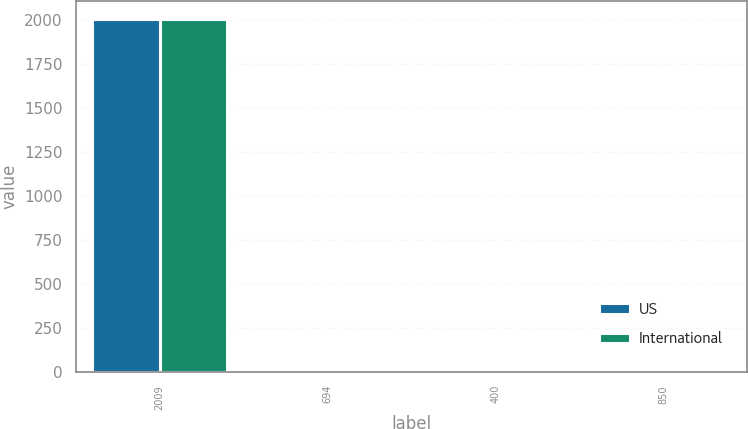Convert chart. <chart><loc_0><loc_0><loc_500><loc_500><stacked_bar_chart><ecel><fcel>2009<fcel>694<fcel>400<fcel>850<nl><fcel>US<fcel>2008<fcel>6.5<fcel>4<fcel>8.5<nl><fcel>International<fcel>2009<fcel>6.81<fcel>4.93<fcel>8.35<nl></chart> 